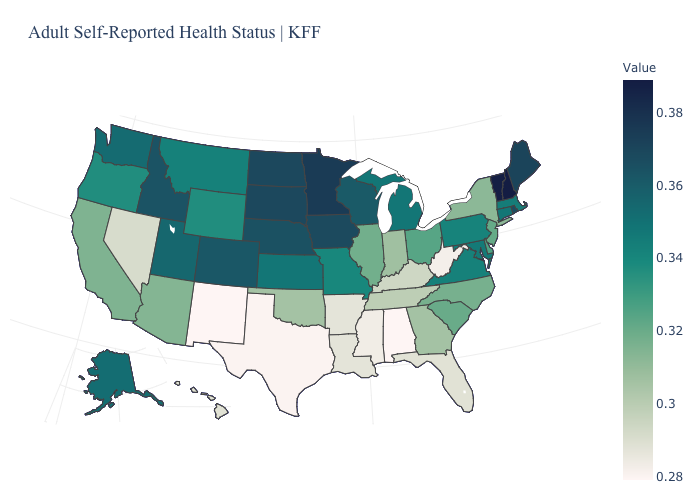Does Arkansas have the lowest value in the USA?
Write a very short answer. No. Does Minnesota have the highest value in the USA?
Quick response, please. No. Which states have the lowest value in the USA?
Be succinct. Alabama, New Mexico. Among the states that border Illinois , does Kentucky have the lowest value?
Be succinct. Yes. Which states have the lowest value in the USA?
Answer briefly. Alabama, New Mexico. Among the states that border Louisiana , does Texas have the highest value?
Write a very short answer. No. Which states have the highest value in the USA?
Answer briefly. New Hampshire. Among the states that border Utah , does Idaho have the lowest value?
Answer briefly. No. 